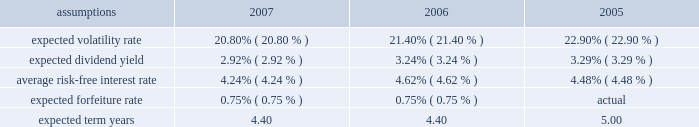Notes to the audited consolidated financial statements for 2007 , 2006 , and 2005 , total share-based compensation expense ( before tax ) of approximately $ 26 million , $ 29 million , and $ 22 million , respectively , was recognized in selling , general and administrative expense in the consolidated statement of earnings for all share-based awards of which approximately $ 13 million , $ 17 million , and $ 5 million , respectively , related to stock options .
Sfas no .
123 ( r ) requires that compensation expense is recognized over the substantive vesting period , which may be a shorter time period than the stated vesting period for retirement-eligible employees .
For 2007 and 2006 , approximately $ 3 million and $ 8 million , respectively , of stock option compensation expense were recognized due to retirement eligibility preceding the requisite vesting period .
Stock option awards option awards are granted on an annual basis to non-employee directors and to employees who meet certain eligibility requirements .
Option awards have an exercise price equal to the closing price of the company's stock on the date of grant .
The term life of options is ten years with vesting periods that vary up to three years .
Vesting usually occurs ratably over the vesting period or at the end of the vesting period .
The company utilizes the black scholes merton ( "bsm" ) option valuation model which relies on certain assumptions to estimate an option's fair value .
The weighted average assumptions used in the determination of fair value for stock options awarded in 2007 , 2006 , and 2005 are provided in the table below: .
The volatility rate of grants is derived from historical company common stock price volatility over the same time period as the expected term of each stock option award .
The volatility rate is derived by mathematical formula utilizing the weekly high closing stock price data over the expected term .
The expected dividend yield is calculated using the expected company annual dividend amount over the expected term divided by the fair market value of the company's common stock .
The average risk-free interest rate is derived from united states department of treasury published interest rates of daily yield curves for the same time period as the expected term .
Sfas no .
123 ( r ) specifies only share-based awards expected to vest be included in share-based compensation expense .
Estimated forfeiture rates are determined using historical forfeiture experience for each type of award and are excluded from the quantity of awards included in share-based compensation expense .
The weighted average expected term reflects the analysis of historical share-based award transactions and includes option swap and reload grants which may have much shorter remaining expected terms than new option grants. .
What was the average expected volatility rate from 2005 to 2007? 
Computations: ((((20.80 + 21.40) + 22.90) + 3) / 2)
Answer: 34.05. 